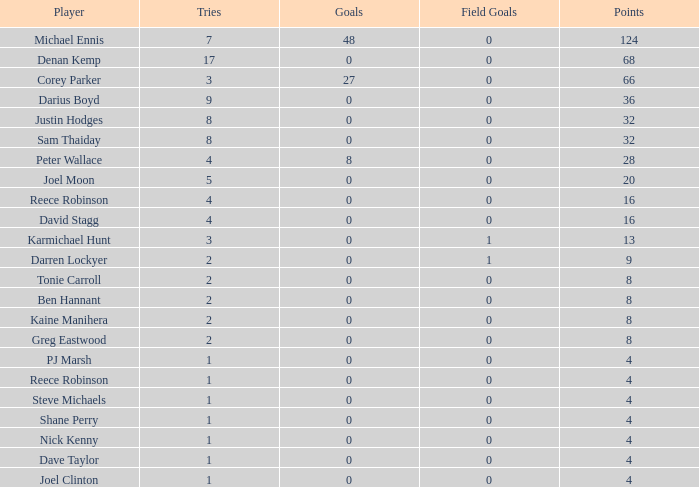How many goals did the player with under 4 points have? 0.0. 